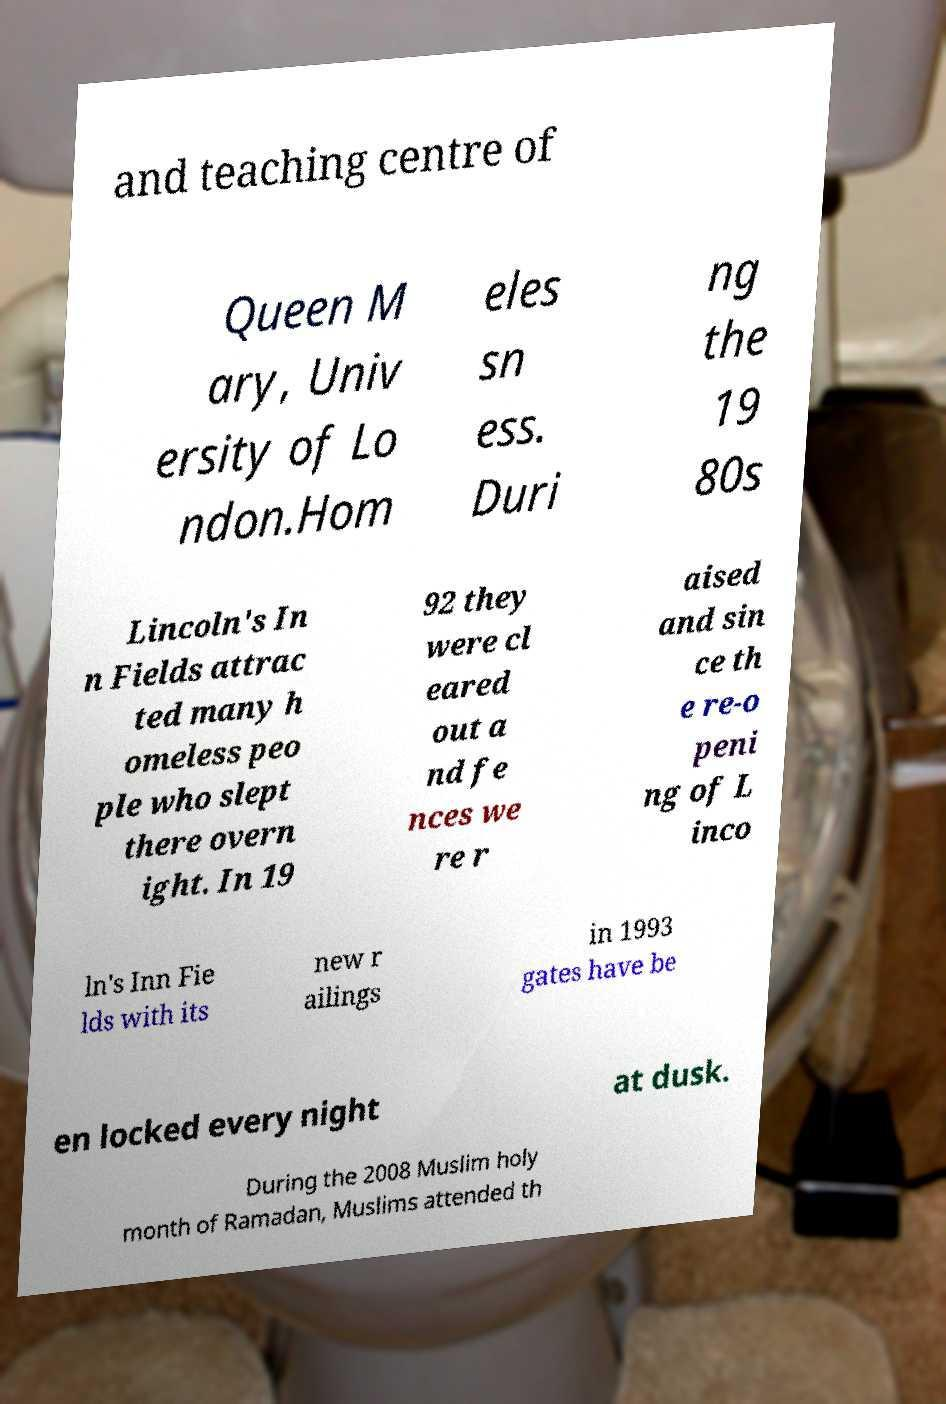There's text embedded in this image that I need extracted. Can you transcribe it verbatim? and teaching centre of Queen M ary, Univ ersity of Lo ndon.Hom eles sn ess. Duri ng the 19 80s Lincoln's In n Fields attrac ted many h omeless peo ple who slept there overn ight. In 19 92 they were cl eared out a nd fe nces we re r aised and sin ce th e re-o peni ng of L inco ln's Inn Fie lds with its new r ailings in 1993 gates have be en locked every night at dusk. During the 2008 Muslim holy month of Ramadan, Muslims attended th 